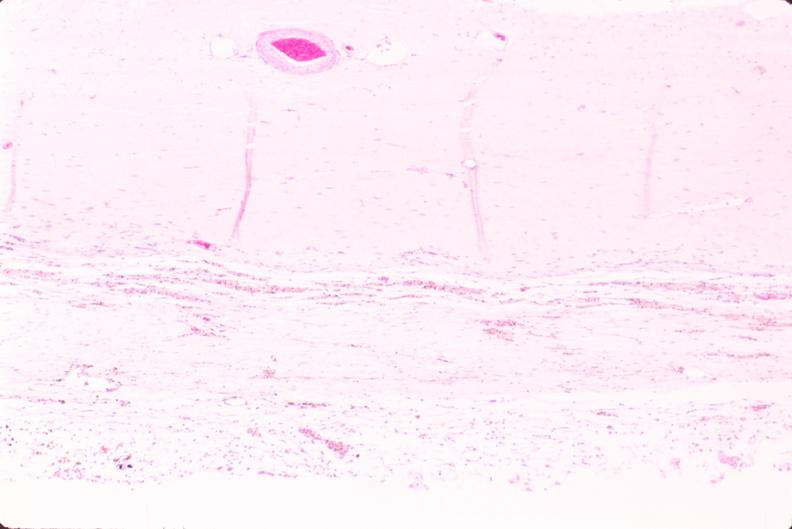where is this?
Answer the question using a single word or phrase. Nervous 